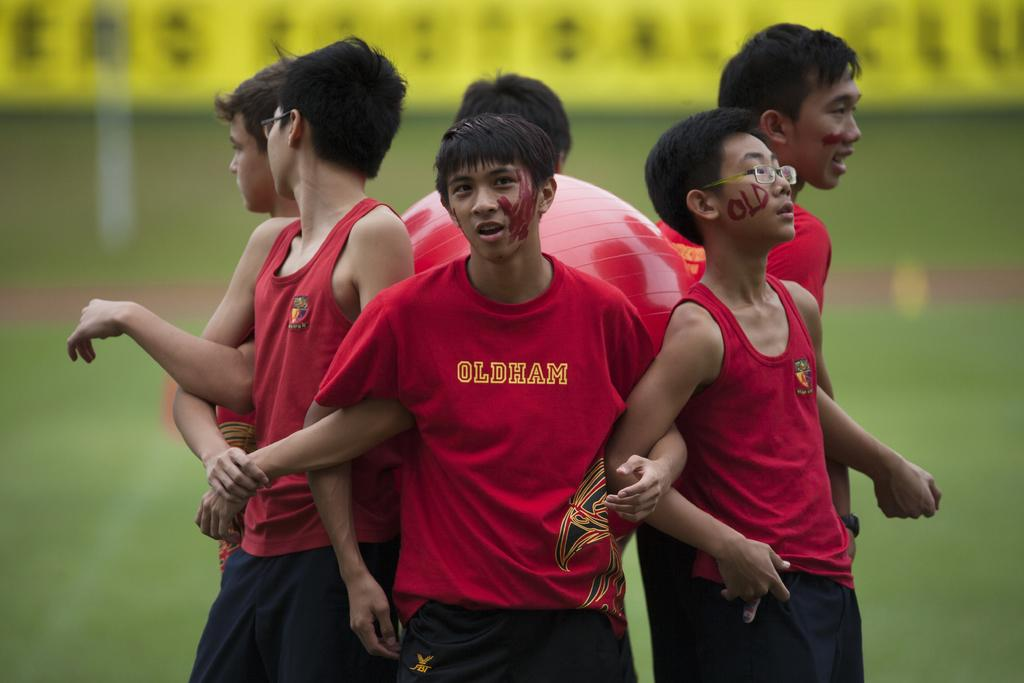How many kids are in the image? There are kids in the image, but the exact number is not specified. What are the kids doing in the image? The kids are standing around a gas ball in the image. What type of haircut does the manager have in the image? There is no manager present in the image, so it is not possible to answer that question. 